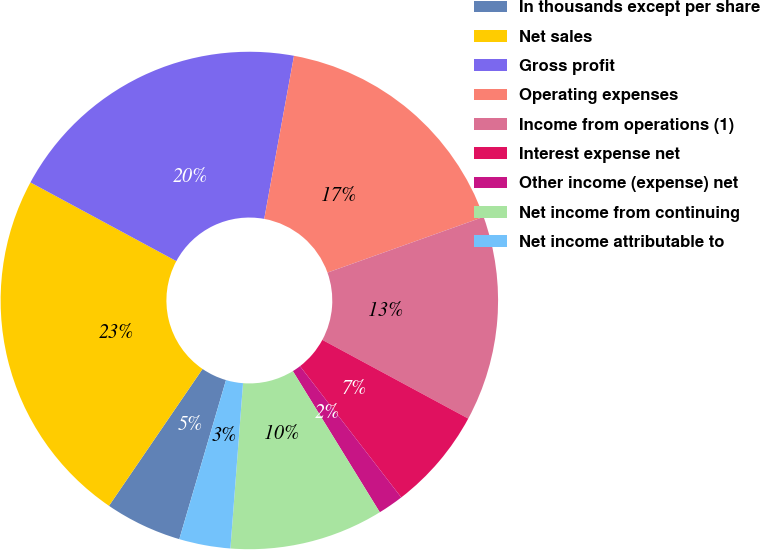Convert chart. <chart><loc_0><loc_0><loc_500><loc_500><pie_chart><fcel>In thousands except per share<fcel>Net sales<fcel>Gross profit<fcel>Operating expenses<fcel>Income from operations (1)<fcel>Interest expense net<fcel>Other income (expense) net<fcel>Net income from continuing<fcel>Net income attributable to<nl><fcel>5.0%<fcel>23.33%<fcel>20.0%<fcel>16.67%<fcel>13.33%<fcel>6.67%<fcel>1.67%<fcel>10.0%<fcel>3.33%<nl></chart> 